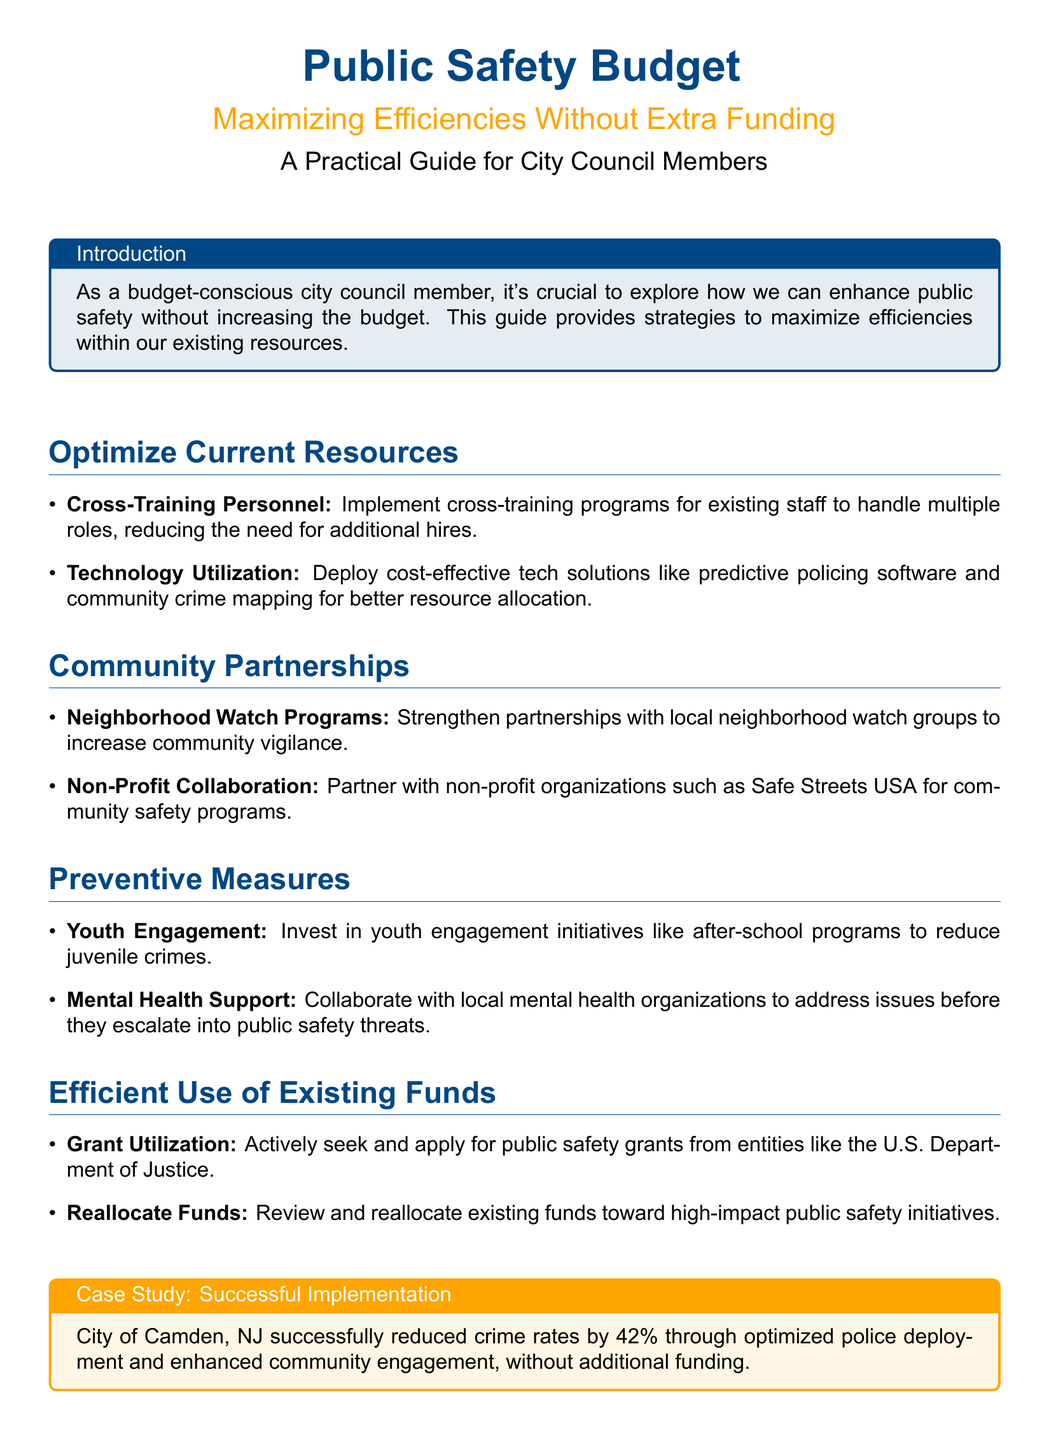What is the title of the flyer? The title of the flyer is prominently displayed at the top of the document.
Answer: Public Safety Budget What is the subtitle of the document? The subtitle provides additional context about the main title and mission.
Answer: Maximizing Efficiencies Without Extra Funding What is one method suggested for optimizing current resources? This information can be found in the section on optimizing resources, which lists strategies.
Answer: Cross-Training Personnel Which city is mentioned in the case study? The case study provides an example of a city that successfully implemented strategies from the guide.
Answer: Camden What percentage reduction in crime is cited in the case study? This statistic illustrates the success of the initiative highlighted in the case study.
Answer: 42% What type of organizations are suggested for collaboration in community partnerships? The document lists specific types of partnerships that could enhance community safety.
Answer: Non-Profit Organizations What is one preventive measure mentioned in the flyer? The document outlines various strategies aimed at improving public safety.
Answer: Youth Engagement What should be actively sought according to the "Efficient Use of Existing Funds" section? This section emphasizes a proactive approach to funding opportunities.
Answer: Grant Utilization What is the phone number provided for contact information? The document concludes with a contact section providing essential information for further inquiries.
Answer: (555) 123-4567 